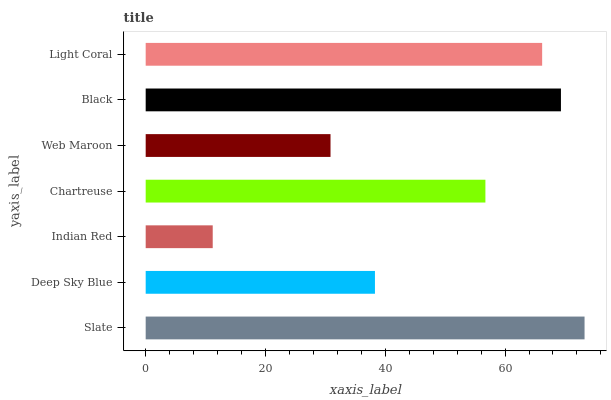Is Indian Red the minimum?
Answer yes or no. Yes. Is Slate the maximum?
Answer yes or no. Yes. Is Deep Sky Blue the minimum?
Answer yes or no. No. Is Deep Sky Blue the maximum?
Answer yes or no. No. Is Slate greater than Deep Sky Blue?
Answer yes or no. Yes. Is Deep Sky Blue less than Slate?
Answer yes or no. Yes. Is Deep Sky Blue greater than Slate?
Answer yes or no. No. Is Slate less than Deep Sky Blue?
Answer yes or no. No. Is Chartreuse the high median?
Answer yes or no. Yes. Is Chartreuse the low median?
Answer yes or no. Yes. Is Web Maroon the high median?
Answer yes or no. No. Is Slate the low median?
Answer yes or no. No. 